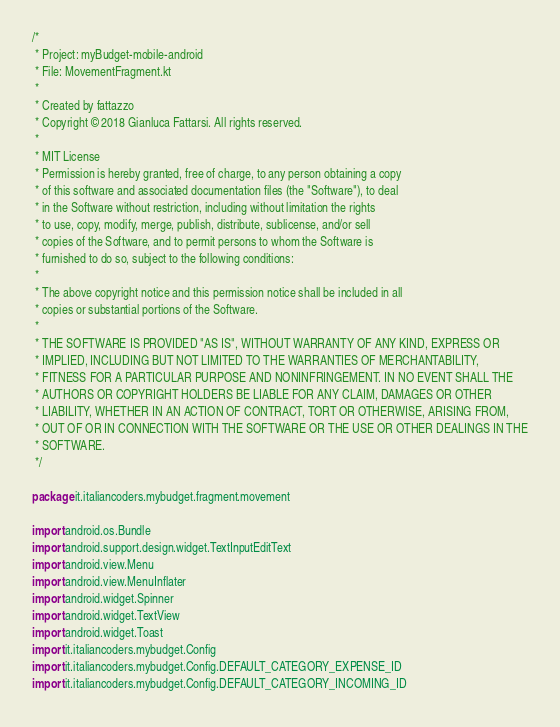<code> <loc_0><loc_0><loc_500><loc_500><_Kotlin_>/*
 * Project: myBudget-mobile-android
 * File: MovementFragment.kt
 *
 * Created by fattazzo
 * Copyright © 2018 Gianluca Fattarsi. All rights reserved.
 *
 * MIT License
 * Permission is hereby granted, free of charge, to any person obtaining a copy
 * of this software and associated documentation files (the "Software"), to deal
 * in the Software without restriction, including without limitation the rights
 * to use, copy, modify, merge, publish, distribute, sublicense, and/or sell
 * copies of the Software, and to permit persons to whom the Software is
 * furnished to do so, subject to the following conditions:
 *
 * The above copyright notice and this permission notice shall be included in all
 * copies or substantial portions of the Software.
 *
 * THE SOFTWARE IS PROVIDED "AS IS", WITHOUT WARRANTY OF ANY KIND, EXPRESS OR
 * IMPLIED, INCLUDING BUT NOT LIMITED TO THE WARRANTIES OF MERCHANTABILITY,
 * FITNESS FOR A PARTICULAR PURPOSE AND NONINFRINGEMENT. IN NO EVENT SHALL THE
 * AUTHORS OR COPYRIGHT HOLDERS BE LIABLE FOR ANY CLAIM, DAMAGES OR OTHER
 * LIABILITY, WHETHER IN AN ACTION OF CONTRACT, TORT OR OTHERWISE, ARISING FROM,
 * OUT OF OR IN CONNECTION WITH THE SOFTWARE OR THE USE OR OTHER DEALINGS IN THE
 * SOFTWARE.
 */

package it.italiancoders.mybudget.fragment.movement

import android.os.Bundle
import android.support.design.widget.TextInputEditText
import android.view.Menu
import android.view.MenuInflater
import android.widget.Spinner
import android.widget.TextView
import android.widget.Toast
import it.italiancoders.mybudget.Config
import it.italiancoders.mybudget.Config.DEFAULT_CATEGORY_EXPENSE_ID
import it.italiancoders.mybudget.Config.DEFAULT_CATEGORY_INCOMING_ID</code> 